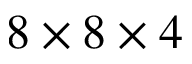Convert formula to latex. <formula><loc_0><loc_0><loc_500><loc_500>8 \times 8 \times 4</formula> 